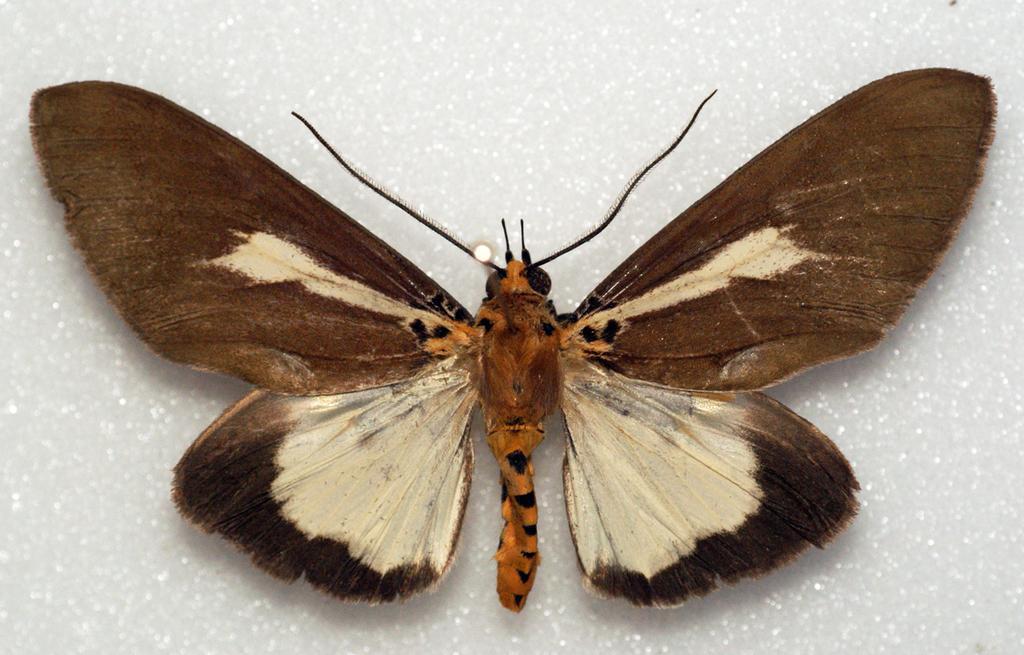How would you summarize this image in a sentence or two? In the image there is a butterfly on the white surface. 